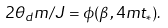Convert formula to latex. <formula><loc_0><loc_0><loc_500><loc_500>2 \theta _ { d } m / J = \phi ( \beta , 4 m t _ { * } ) .</formula> 